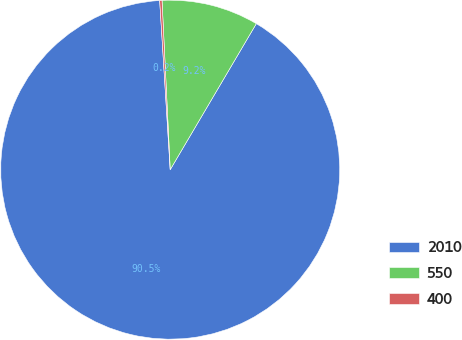Convert chart. <chart><loc_0><loc_0><loc_500><loc_500><pie_chart><fcel>2010<fcel>550<fcel>400<nl><fcel>90.53%<fcel>9.25%<fcel>0.22%<nl></chart> 